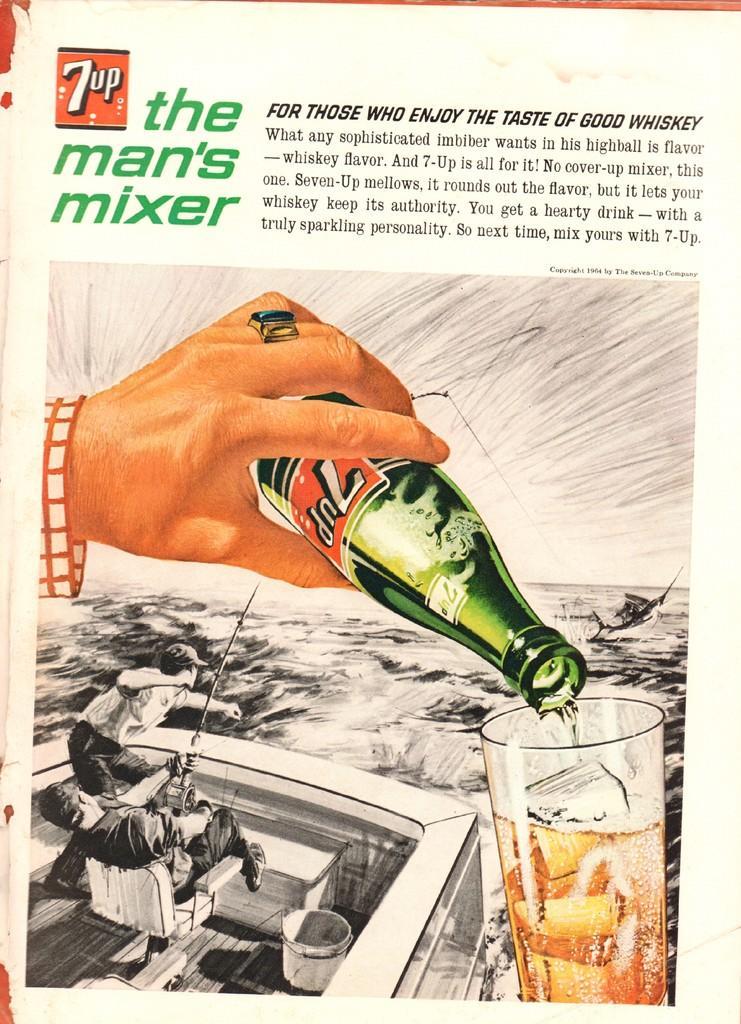Please provide a concise description of this image. This might be a poster, in this image there is text and in the center there is one person's hand is visible and the person is holding a bottle and pouring drink into the glass. At the bottom there is ship, and in the ship there is one person and some objects and a bucket and there is a river. And in the background there is another boat. 